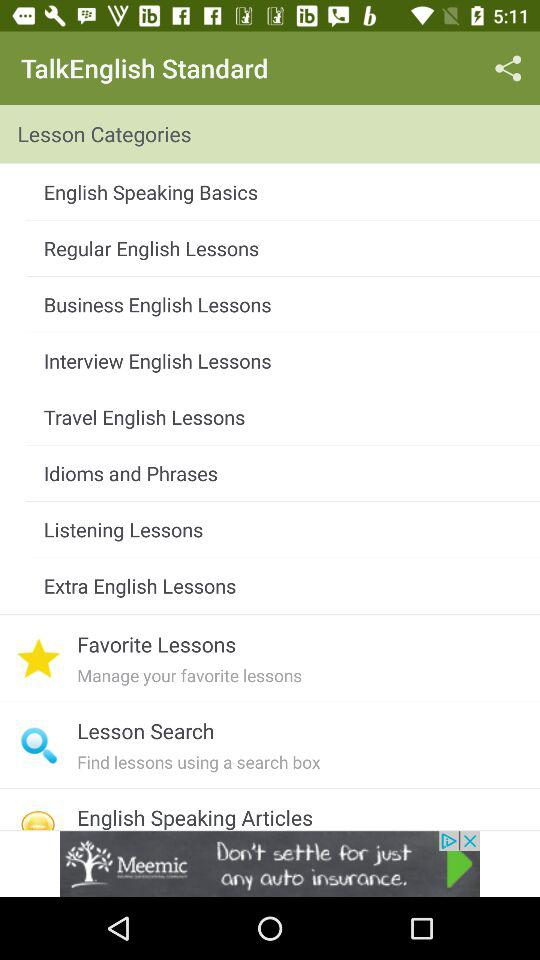What is the application name? The application name is "TalkEnglish Standard". 